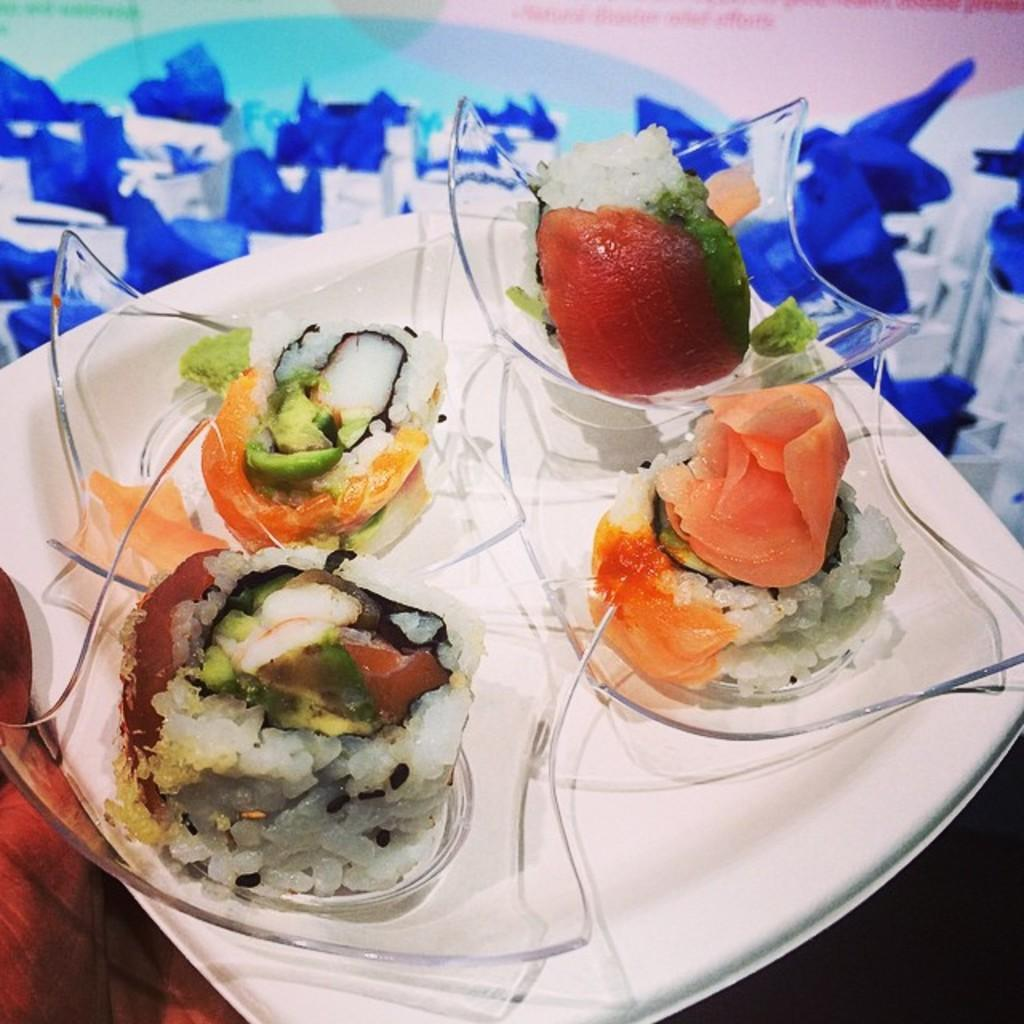What is placed on the plate in the image? There is food placed in a plate in the image. What can be seen in the background of the image? There is a poster in the backdrop of the image. What colors are used in the poster? The poster has white and blue images on it. What type of feather can be seen on the road in the image? There is no road or feather present in the image. 